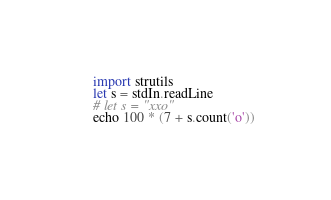<code> <loc_0><loc_0><loc_500><loc_500><_Nim_>import strutils
let s = stdIn.readLine
# let s = "xxo"
echo 100 * (7 + s.count('o'))
</code> 